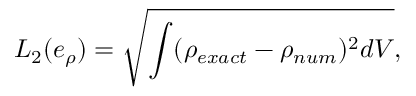<formula> <loc_0><loc_0><loc_500><loc_500>L _ { 2 } ( e _ { \rho } ) = \sqrt { \int ( \rho _ { e x a c t } - \rho _ { n u m } ) ^ { 2 } d V } ,</formula> 